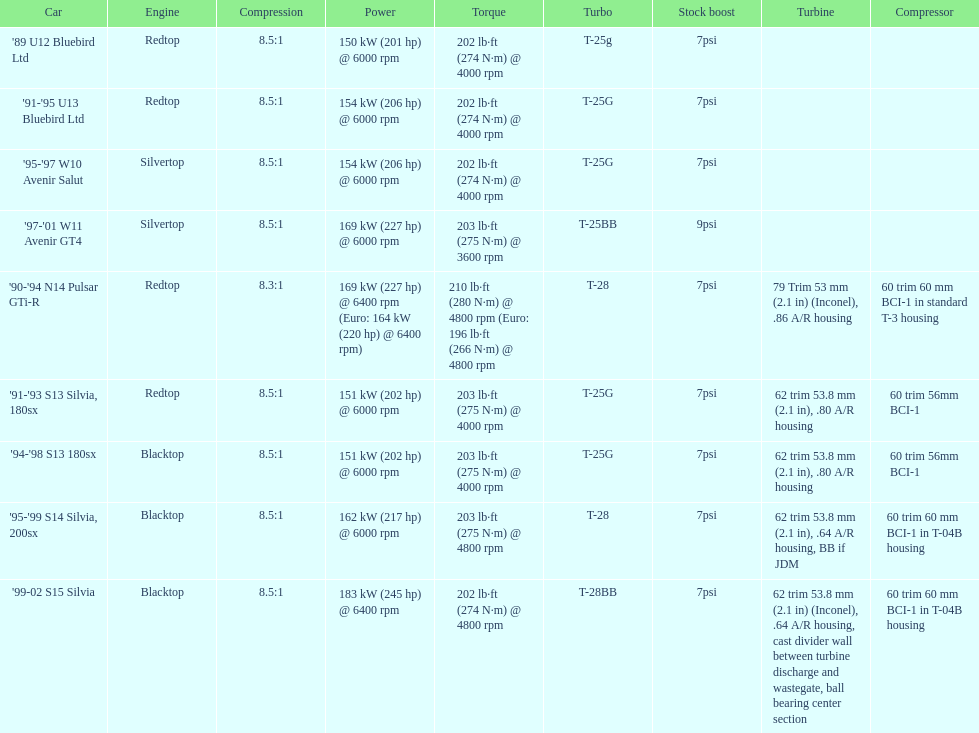What compression does the 90-94 n14 pulsar gti-r have? 8.3:1. 